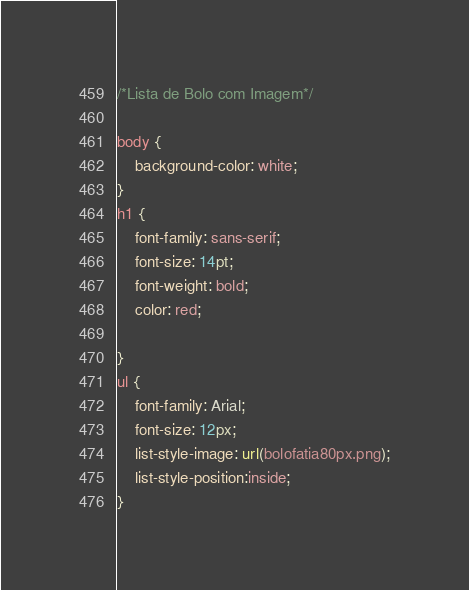<code> <loc_0><loc_0><loc_500><loc_500><_CSS_>/*Lista de Bolo com Imagem*/

body {
    background-color: white;
}
h1 {
    font-family: sans-serif;
    font-size: 14pt;
    font-weight: bold;
    color: red;
    
}
ul {
    font-family: Arial;
    font-size: 12px;
    list-style-image: url(bolofatia80px.png);
    list-style-position:inside;   
}


</code> 